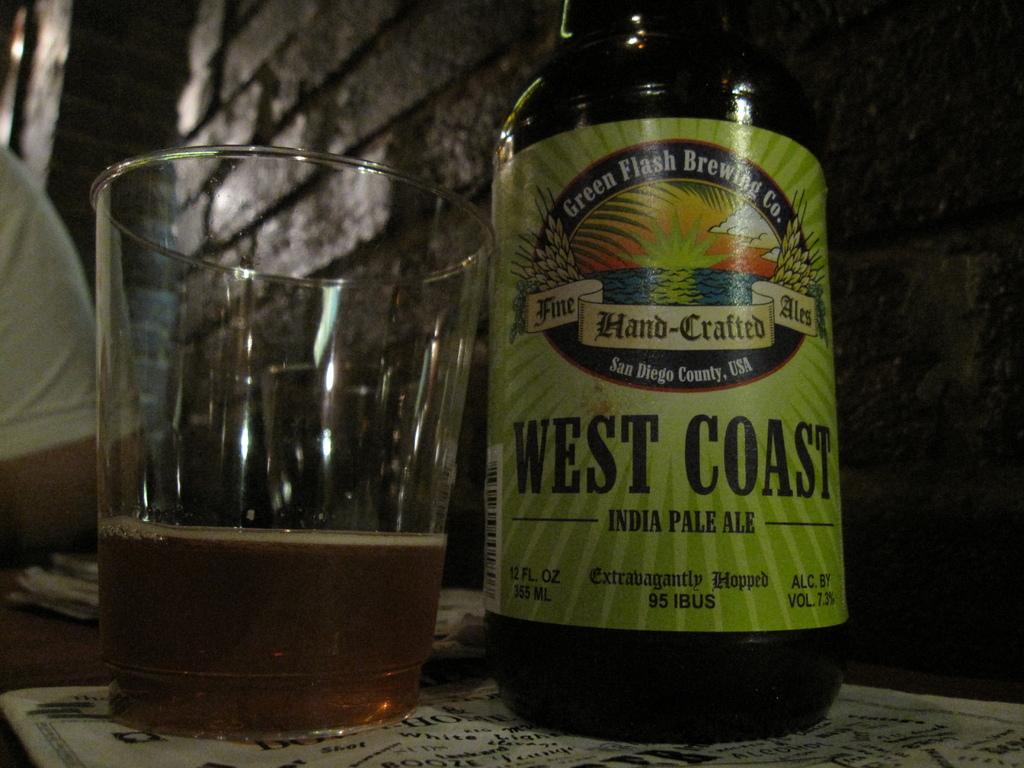What kind of beer is this?
Provide a succinct answer. West coast india pale ale. How was this beer crafted?
Offer a very short reply. Hand-crafted. 